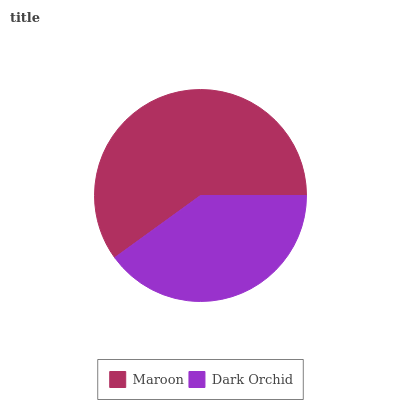Is Dark Orchid the minimum?
Answer yes or no. Yes. Is Maroon the maximum?
Answer yes or no. Yes. Is Dark Orchid the maximum?
Answer yes or no. No. Is Maroon greater than Dark Orchid?
Answer yes or no. Yes. Is Dark Orchid less than Maroon?
Answer yes or no. Yes. Is Dark Orchid greater than Maroon?
Answer yes or no. No. Is Maroon less than Dark Orchid?
Answer yes or no. No. Is Maroon the high median?
Answer yes or no. Yes. Is Dark Orchid the low median?
Answer yes or no. Yes. Is Dark Orchid the high median?
Answer yes or no. No. Is Maroon the low median?
Answer yes or no. No. 